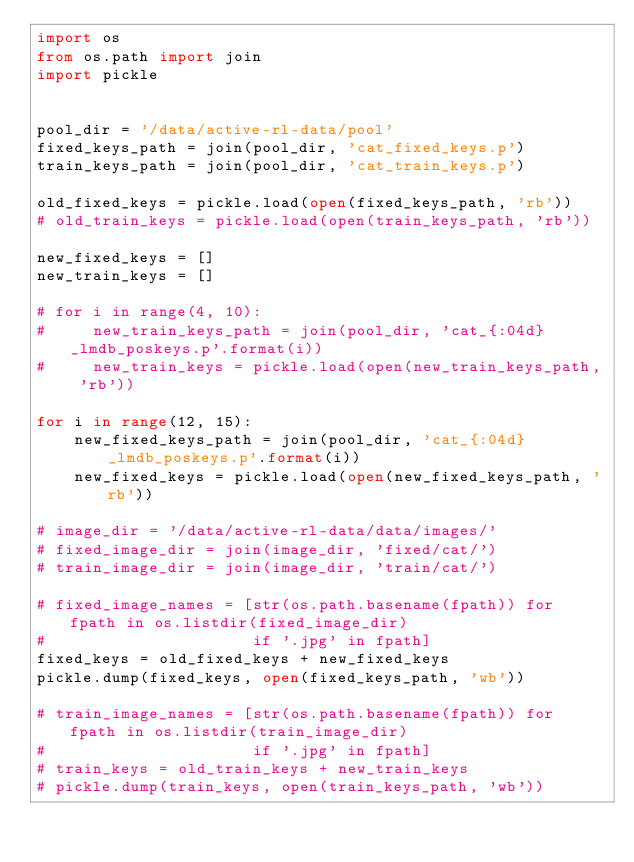Convert code to text. <code><loc_0><loc_0><loc_500><loc_500><_Python_>import os
from os.path import join
import pickle


pool_dir = '/data/active-rl-data/pool'
fixed_keys_path = join(pool_dir, 'cat_fixed_keys.p')
train_keys_path = join(pool_dir, 'cat_train_keys.p')

old_fixed_keys = pickle.load(open(fixed_keys_path, 'rb'))
# old_train_keys = pickle.load(open(train_keys_path, 'rb'))

new_fixed_keys = []
new_train_keys = []

# for i in range(4, 10):
#     new_train_keys_path = join(pool_dir, 'cat_{:04d}_lmdb_poskeys.p'.format(i))
#     new_train_keys = pickle.load(open(new_train_keys_path, 'rb'))

for i in range(12, 15):
    new_fixed_keys_path = join(pool_dir, 'cat_{:04d}_lmdb_poskeys.p'.format(i))
    new_fixed_keys = pickle.load(open(new_fixed_keys_path, 'rb'))

# image_dir = '/data/active-rl-data/data/images/'
# fixed_image_dir = join(image_dir, 'fixed/cat/')
# train_image_dir = join(image_dir, 'train/cat/')

# fixed_image_names = [str(os.path.basename(fpath)) for fpath in os.listdir(fixed_image_dir)
#                      if '.jpg' in fpath]
fixed_keys = old_fixed_keys + new_fixed_keys
pickle.dump(fixed_keys, open(fixed_keys_path, 'wb'))

# train_image_names = [str(os.path.basename(fpath)) for fpath in os.listdir(train_image_dir)
#                      if '.jpg' in fpath]
# train_keys = old_train_keys + new_train_keys
# pickle.dump(train_keys, open(train_keys_path, 'wb'))

</code> 